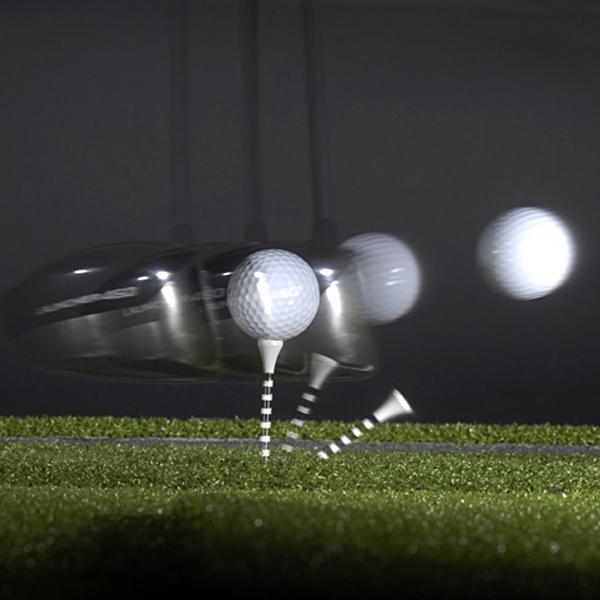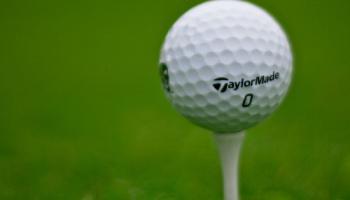The first image is the image on the left, the second image is the image on the right. Assess this claim about the two images: "Right image shows one white golf ball perched on a tee.". Correct or not? Answer yes or no. Yes. The first image is the image on the left, the second image is the image on the right. Given the left and right images, does the statement "The ball in the image on the right is sitting on a white tee." hold true? Answer yes or no. Yes. 